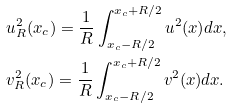Convert formula to latex. <formula><loc_0><loc_0><loc_500><loc_500>& u ^ { 2 } _ { R } ( x _ { c } ) = \frac { 1 } { R } \int ^ { x _ { c } + R / 2 } _ { x _ { c } - R / 2 } u ^ { 2 } ( x ) d x , \\ & v ^ { 2 } _ { R } ( x _ { c } ) = \frac { 1 } { R } \int ^ { x _ { c } + R / 2 } _ { x _ { c } - R / 2 } v ^ { 2 } ( x ) d x .</formula> 